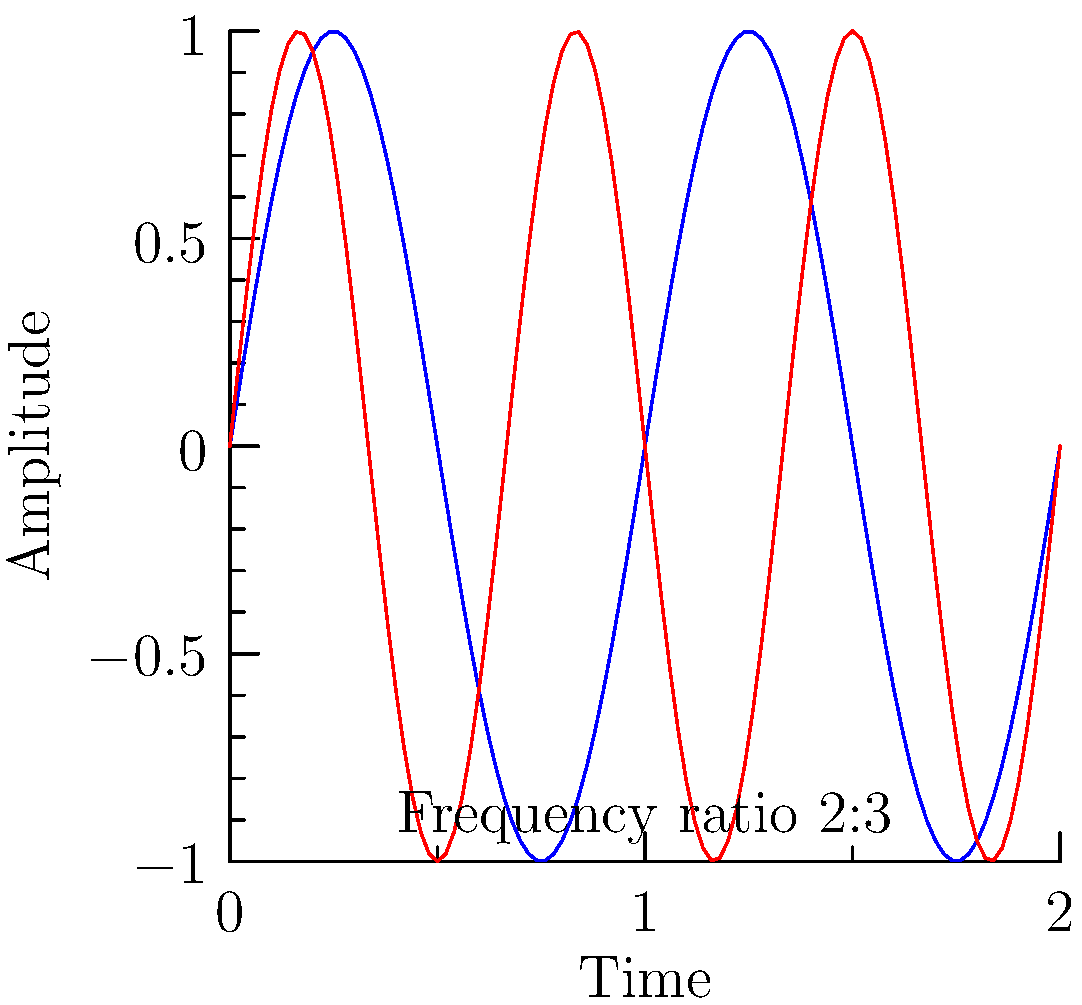In the graph above, two sine waves are shown representing different musical frequencies. The blue wave represents a fundamental frequency, while the red wave represents a higher frequency. Given that these waves form a consonant interval, what is the most likely musical interval represented, and how does this relate to the concept of just intonation in music theory? To answer this question, we need to follow these steps:

1. Observe the frequency ratio:
   The red wave completes 3 cycles for every 2 cycles of the blue wave. This indicates a frequency ratio of 3:2.

2. Relate the frequency ratio to musical intervals:
   In music theory, frequency ratios correspond to specific intervals. The 3:2 ratio is associated with the perfect fifth.

3. Understand just intonation:
   Just intonation is a tuning system where intervals are based on whole number ratios of frequencies. The 3:2 ratio is a prime example of just intonation.

4. Consonance in music:
   Consonant intervals are generally perceived as pleasant and stable. The perfect fifth is one of the most consonant intervals after the octave.

5. Mathematical basis:
   The consonance of the perfect fifth can be explained mathematically. When frequency ratios are simple (like 3:2), the waveforms align more frequently, creating a stable sound.

6. Visualize the alignment:
   In the graph, we can see that the waves align every two cycles of the blue wave (or three cycles of the red wave), contributing to the perceived consonance.

7. Relate to the musical context:
   For a young musician exploring mathematical concepts in music, understanding these frequency relationships is crucial for comprehending harmony, tuning systems, and the physics of sound.
Answer: Perfect fifth; 3:2 frequency ratio in just intonation 